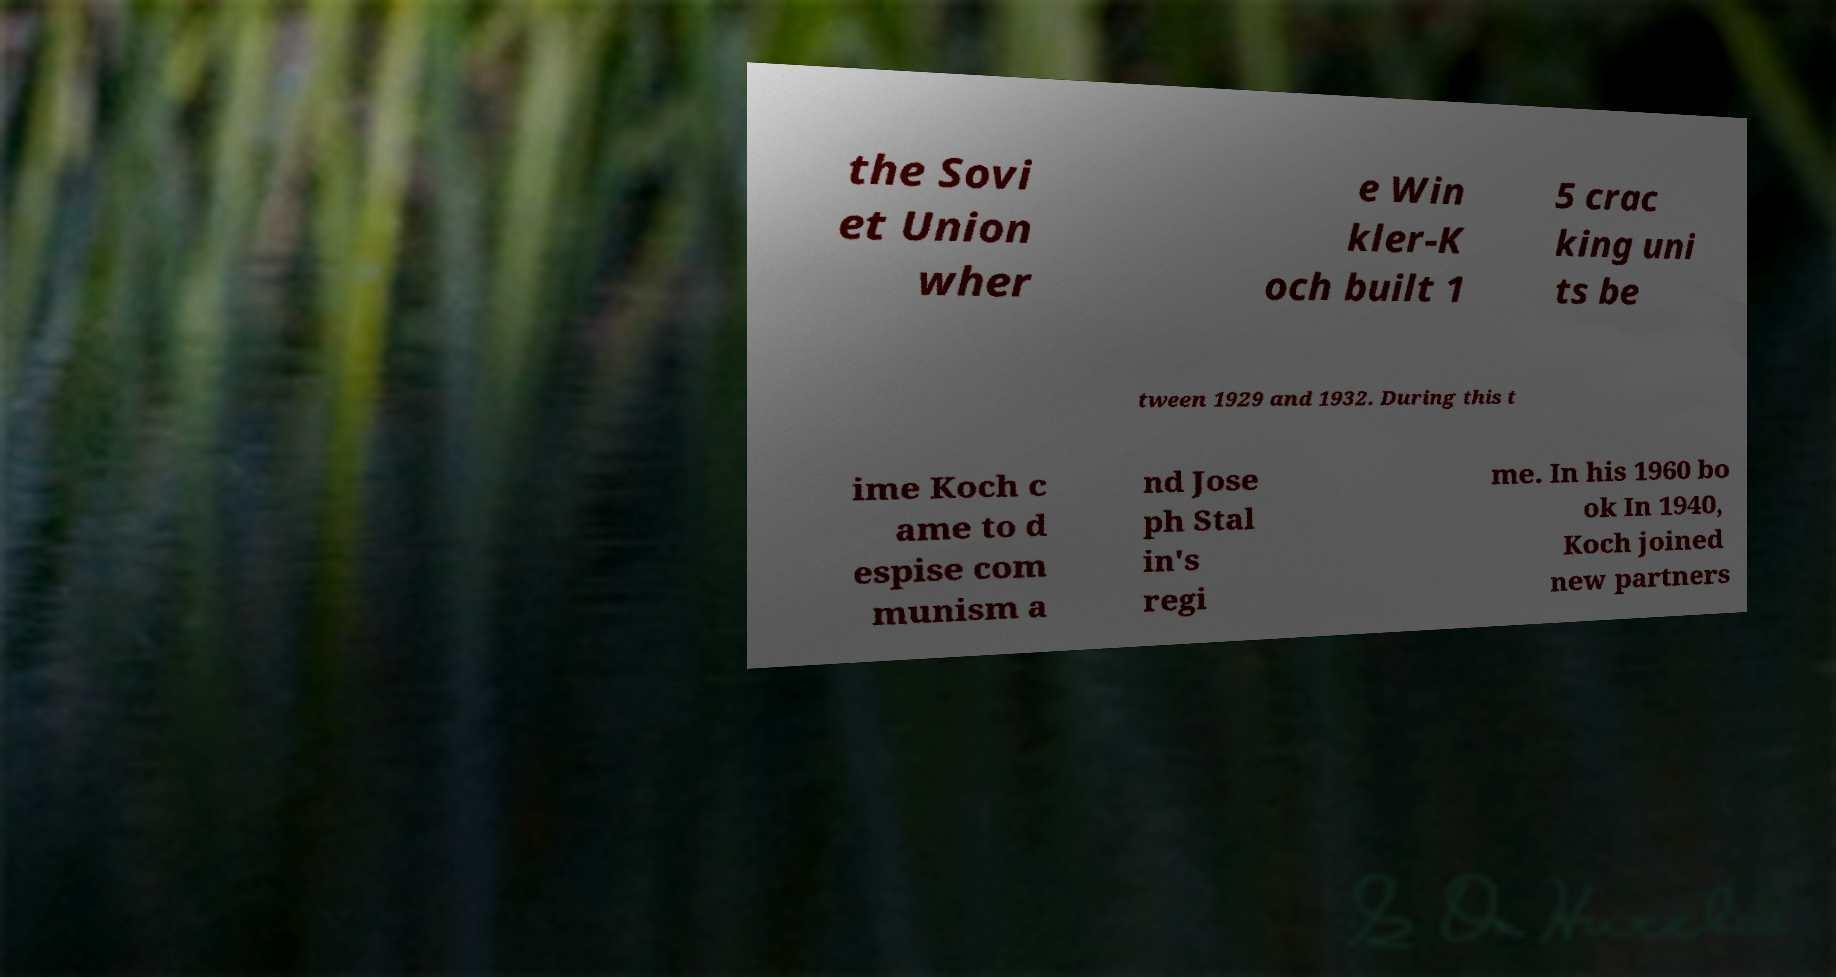What messages or text are displayed in this image? I need them in a readable, typed format. the Sovi et Union wher e Win kler-K och built 1 5 crac king uni ts be tween 1929 and 1932. During this t ime Koch c ame to d espise com munism a nd Jose ph Stal in's regi me. In his 1960 bo ok In 1940, Koch joined new partners 